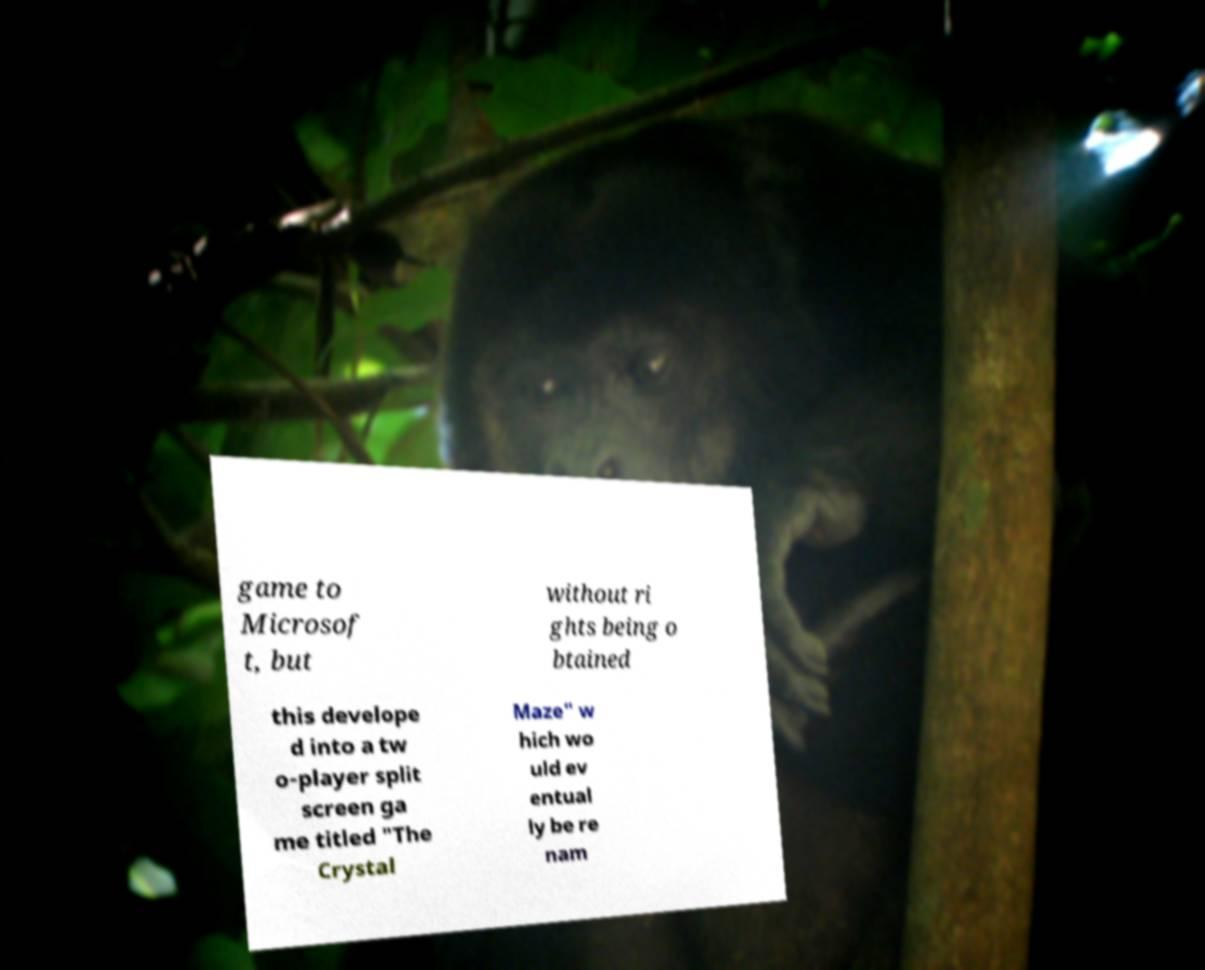Could you assist in decoding the text presented in this image and type it out clearly? game to Microsof t, but without ri ghts being o btained this develope d into a tw o-player split screen ga me titled "The Crystal Maze" w hich wo uld ev entual ly be re nam 